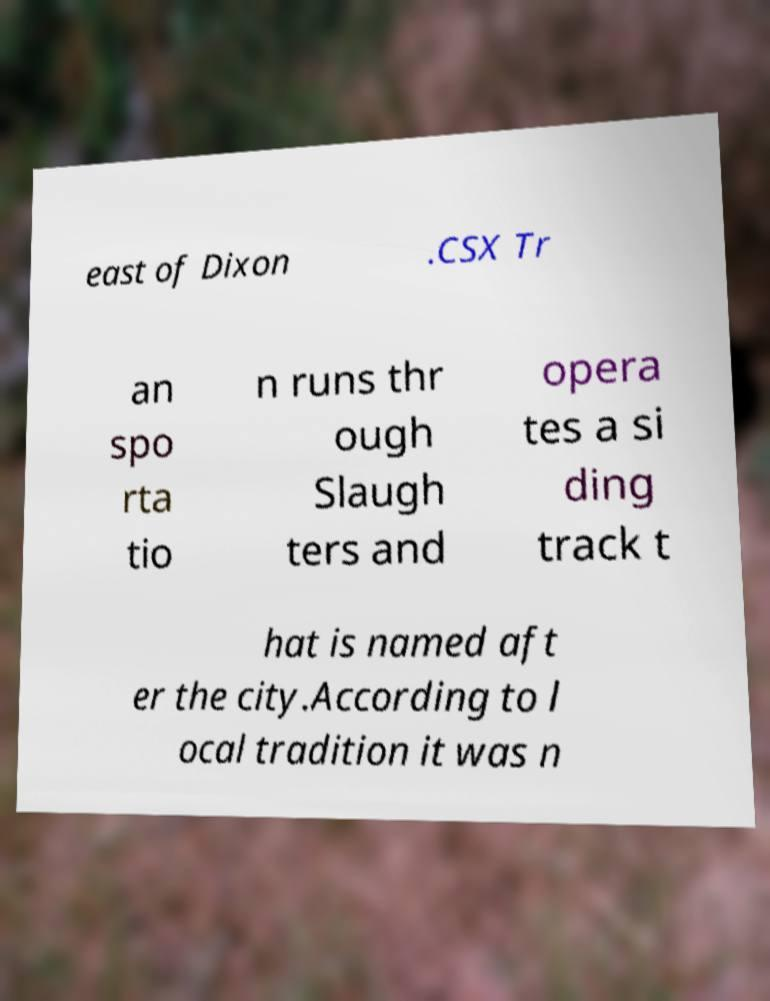Could you assist in decoding the text presented in this image and type it out clearly? east of Dixon .CSX Tr an spo rta tio n runs thr ough Slaugh ters and opera tes a si ding track t hat is named aft er the city.According to l ocal tradition it was n 